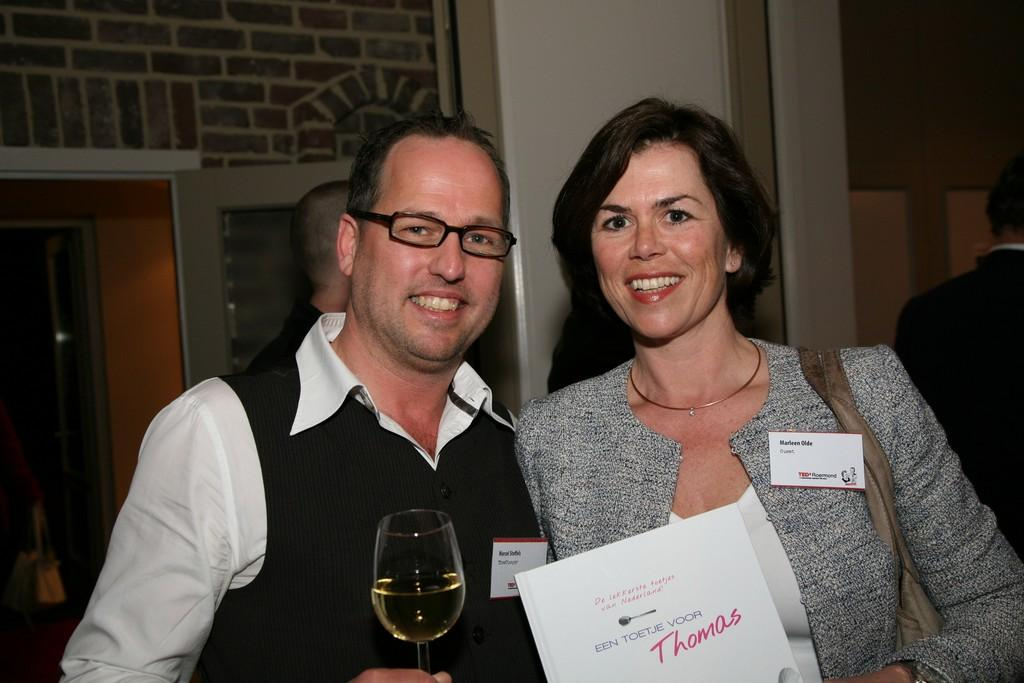<image>
Summarize the visual content of the image. A man and woman pose with a paper that says "Thomas" in red letters. 